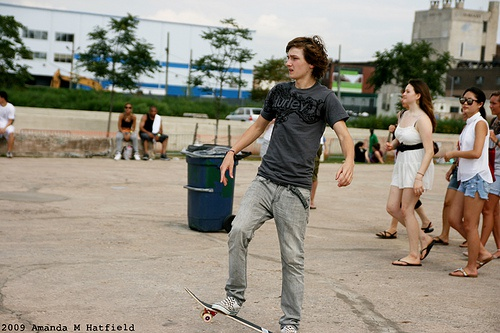Describe the objects in this image and their specific colors. I can see people in lightgray, black, gray, and darkgray tones, people in lightgray, tan, and darkgray tones, people in lightgray, brown, maroon, and gray tones, people in lightgray, maroon, brown, black, and darkgray tones, and people in lightgray, black, maroon, and lavender tones in this image. 